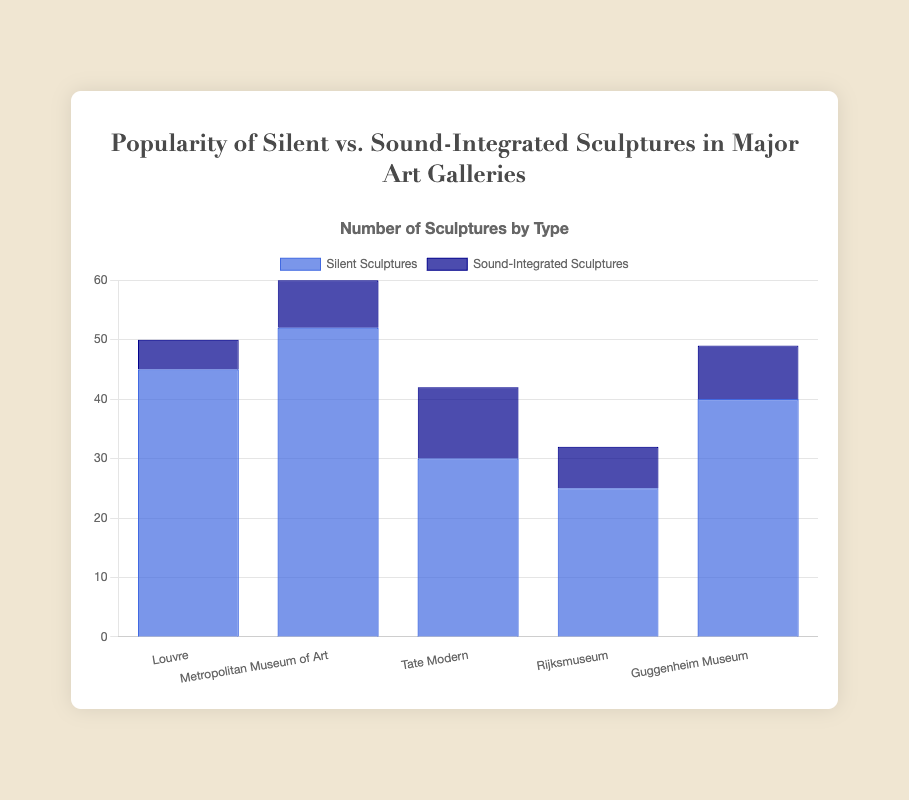How many silent sculptures are displayed in total in the Louvre and the Tate Modern? We need to sum the number of silent sculptures in both the Louvre and the Tate Modern. According to the data: Louvre has 45 and Tate Modern has 30. So, 45 + 30 = 75.
Answer: 75 Which gallery has more sound-integrated sculptures, the Guggenheim Museum or the Rijksmuseum? To find out which gallery has more, we compare the number of sound-integrated sculptures: Guggenheim Museum has 9 while Rijksmuseum has 7. 9 is greater than 7.
Answer: Guggenheim Museum What is the total number of sculptures (both silent and sound-integrated) in the Metropolitan Museum of Art? Sum both the silent and sound-integrated sculptures in the Metropolitan Museum of Art: Silent sculptures (52) + Sound-integrated sculptures (8) = 60.
Answer: 60 Among the listed galleries, which has the least number of silent sculptures? We check the numbers of silent sculptures and find the smallest value: Louvre (45), Metropolitan Museum of Art (52), Tate Modern (30), Rijksmuseum (25), Guggenheim Museum (40). The smallest is 25 in Rijksmuseum.
Answer: Rijksmuseum What is the percentage of sound-integrated sculptures out of the total sculptures in the Tate Modern? To find the percentage: First, calculate the total sculptures in Tate Modern (silent = 30, sound-integrated = 12), so total = 30 + 12 = 42. Then, (sound-integrated / total) * 100 = (12 / 42) * 100 ≈ 28.57%.
Answer: 28.57% Compare the total number of silent sculptures to the total number of sound-integrated sculptures across all galleries. Which type is more prevalent? First, calculate the total for each type: Silent sculptures: 45 (Louvre) + 52 (Metropolitan Museum of Art) + 30 (Tate Modern) + 25 (Rijksmuseum) + 40 (Guggenheim Museum) = 192. Sound-integrated sculptures: 5 (Louvre) + 8 (Metropolitan Museum of Art) + 12 (Tate Modern) + 7 (Rijksmuseum) + 9 (Guggenheim Museum) = 41. Silent sculptures (192) are more prevalent than sound-integrated (41).
Answer: Silent sculptures By how many sculptures does the number of silent sculptures at the Louvre exceed those at the Guggenheim Museum? Subtract the number of silent sculptures at the Guggenheim Museum from the number at the Louvre: 45 (Louvre) - 40 (Guggenheim Museum) = 5.
Answer: 5 How many more silent sculptures are there than sound-integrated sculptures in the Native Modern? Subtract the number of sound-integrated sculptures from the number of silent sculptures in the Tate Modern: 30 (silent) - 12 (sound-integrated) = 18.
Answer: 18 Which gallery has the highest number of sculptures in total and what is the count? Calculate the total number of sculptures in each gallery and compare: Louvre (45 silent + 5 sound-integrated = 50), Metropolitan Museum of Art (52 + 8 = 60), Tate Modern (30 + 12 = 42), Rijksmuseum (25 + 7 = 32), Guggenheim Museum (40 + 9 = 49). The Metropolitan Museum of Art has the highest total with 60 sculptures.
Answer: Metropolitan Museum of Art, 60 